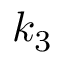<formula> <loc_0><loc_0><loc_500><loc_500>k _ { 3 }</formula> 